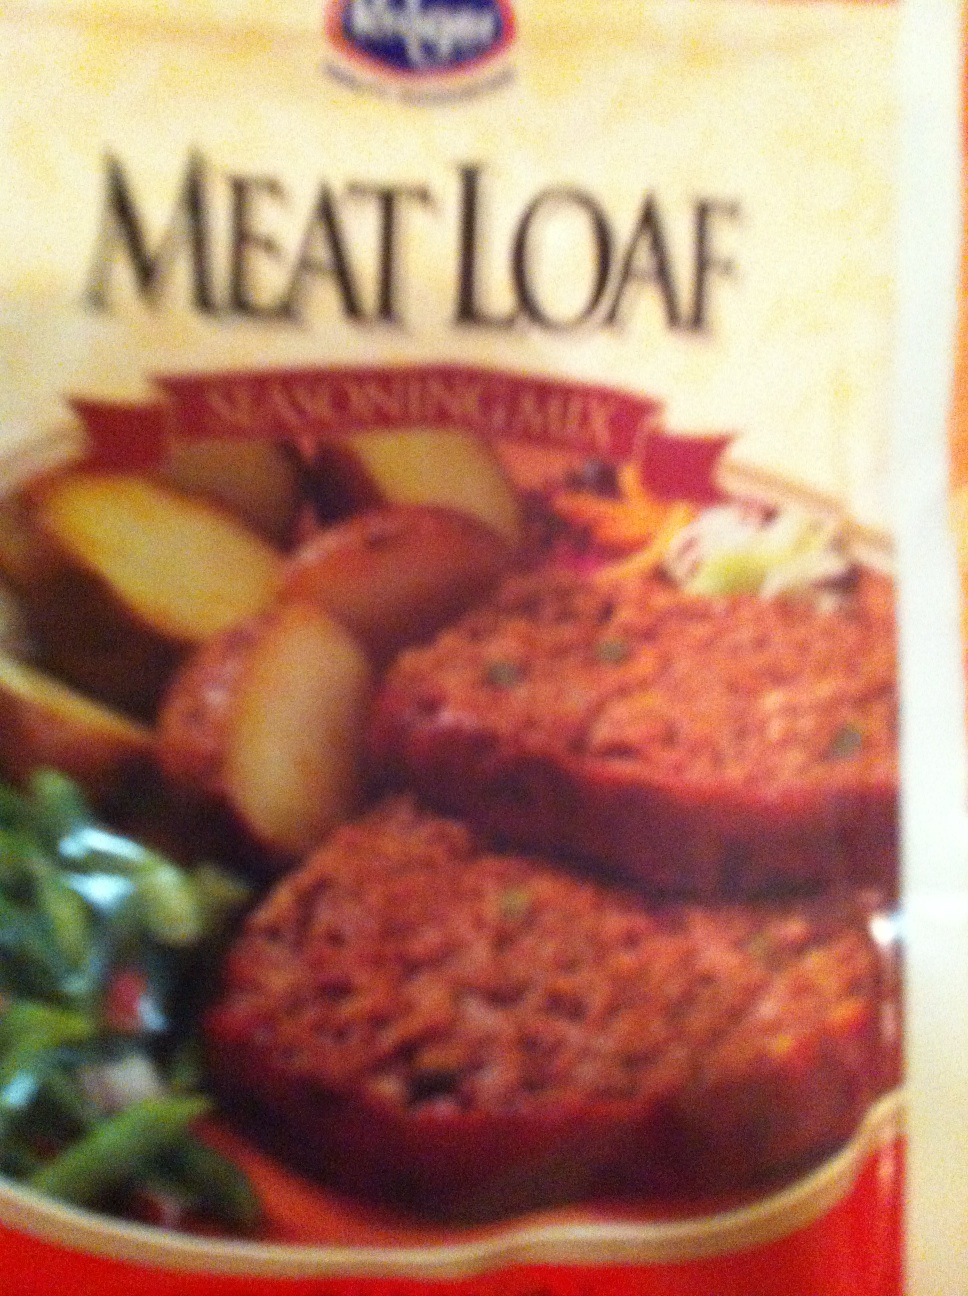What makes this meatloaf special compared to others? This meatloaf might be special due to its seasoning blend, convenience of being pre-made, or specific ingredients that set it apart from homemade versions. Brands often use unique spice profiles or add-ins like diced vegetables or cheese to distinguish their products. 